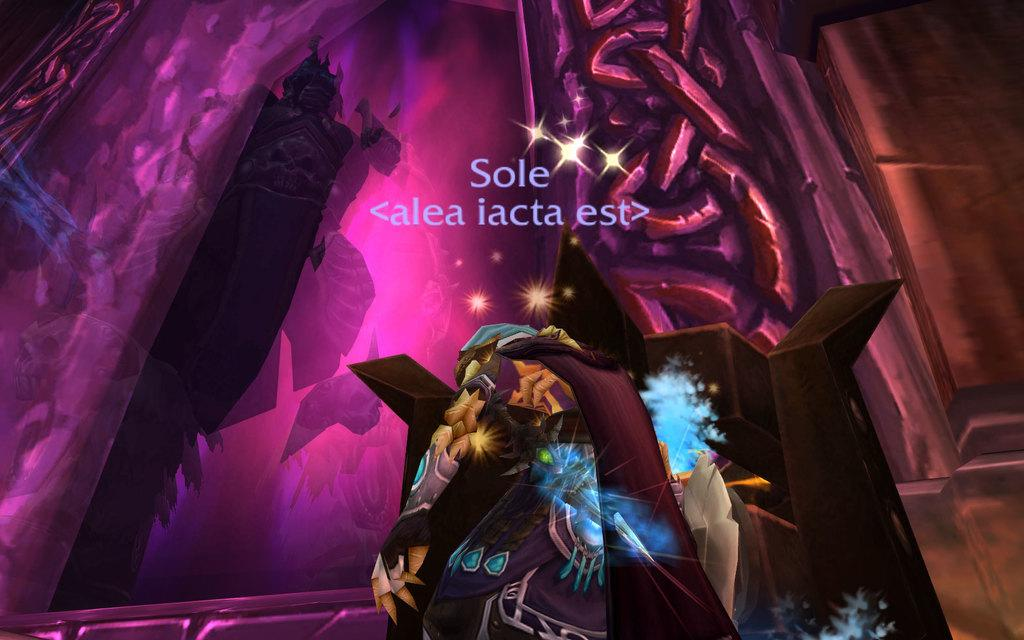What is the main subject of the image? There is an animation of a person in the image. Are there any other elements in the animation besides the person? Yes, there are other things in the animation. Is there any text present in the image? Yes, there is text written on the image. How many beds are visible in the animation? There are no beds present in the animation or the image. 